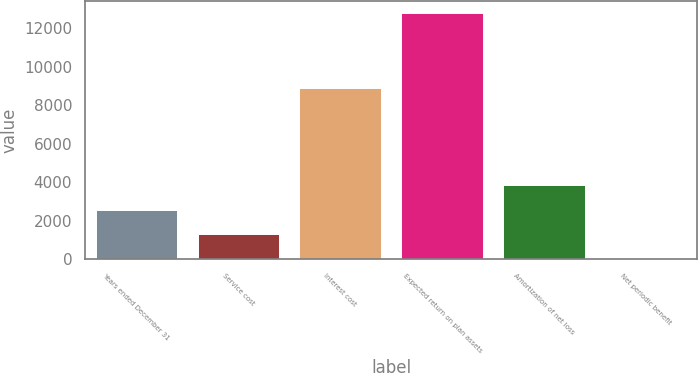Convert chart. <chart><loc_0><loc_0><loc_500><loc_500><bar_chart><fcel>Years ended December 31<fcel>Service cost<fcel>Interest cost<fcel>Expected return on plan assets<fcel>Amortization of net loss<fcel>Net periodic benefit<nl><fcel>2578.4<fcel>1302.2<fcel>8915<fcel>12788<fcel>3854.6<fcel>26<nl></chart> 